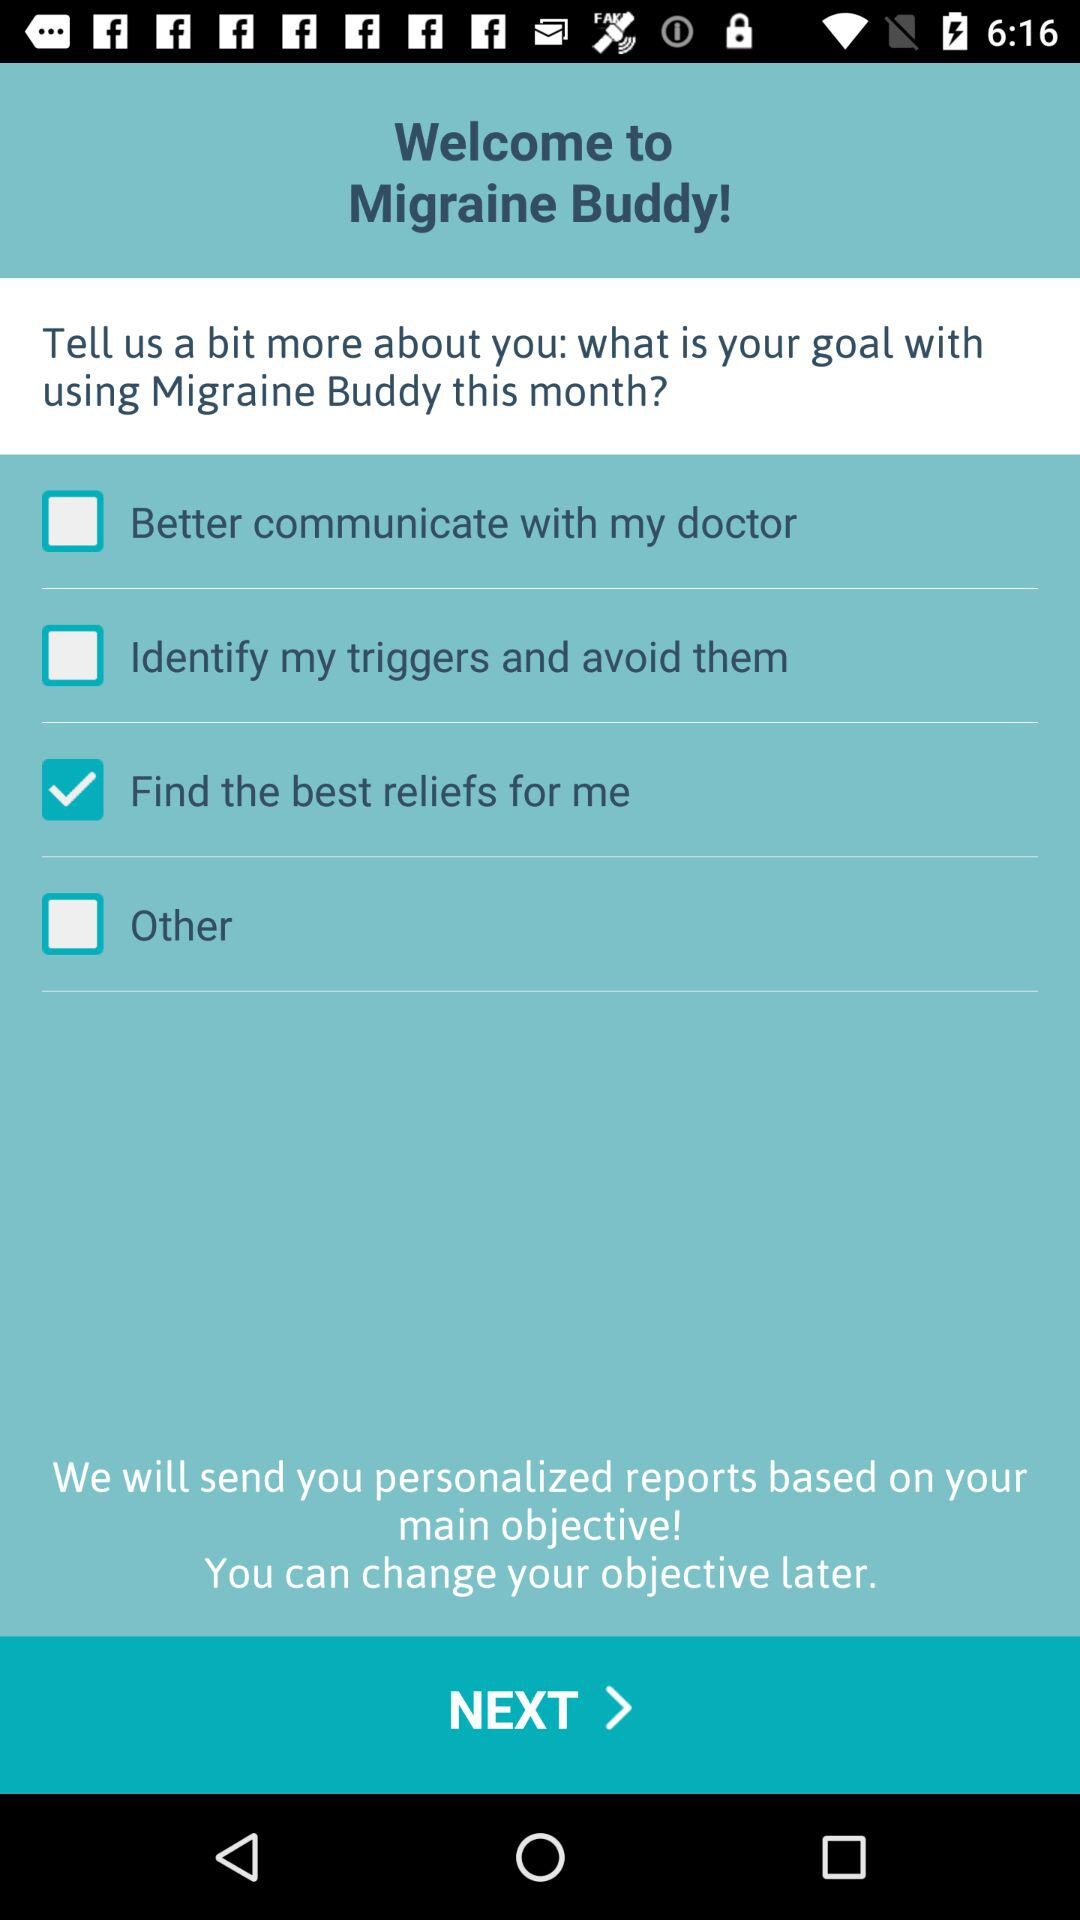What is the current status of "Better communicate with my doctor"? The current status of "Better communicate with my doctor" is "off". 